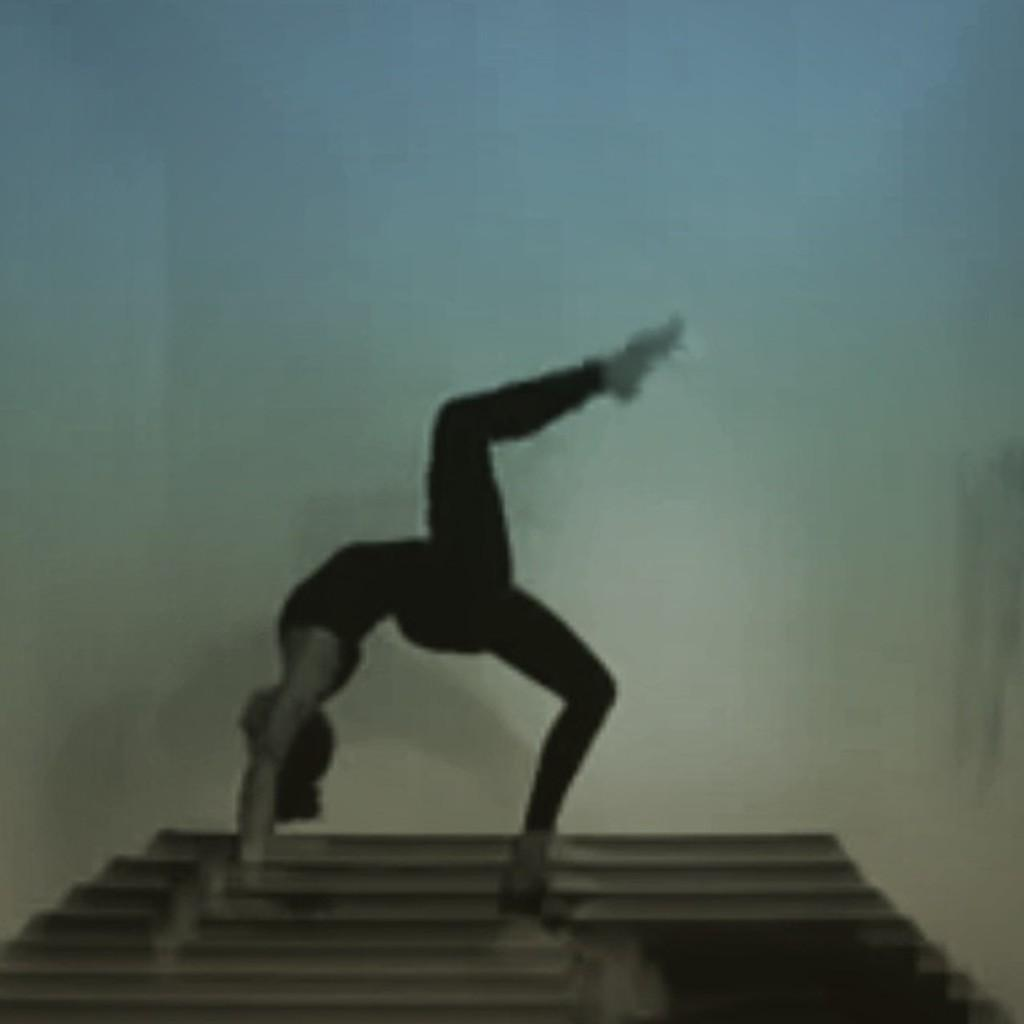What can be observed about the image's appearance? The image appears to be edited. What is the main subject of the image? There is a person in a pose in the image. What color is predominant in the background of the image? The background of the image has a bluish color. What is present at the bottom of the image? There is a mat at the bottom of the image. What type of humor is being expressed by the writer in the image? There is no writer present in the image, and therefore no humor can be attributed to a writer. 